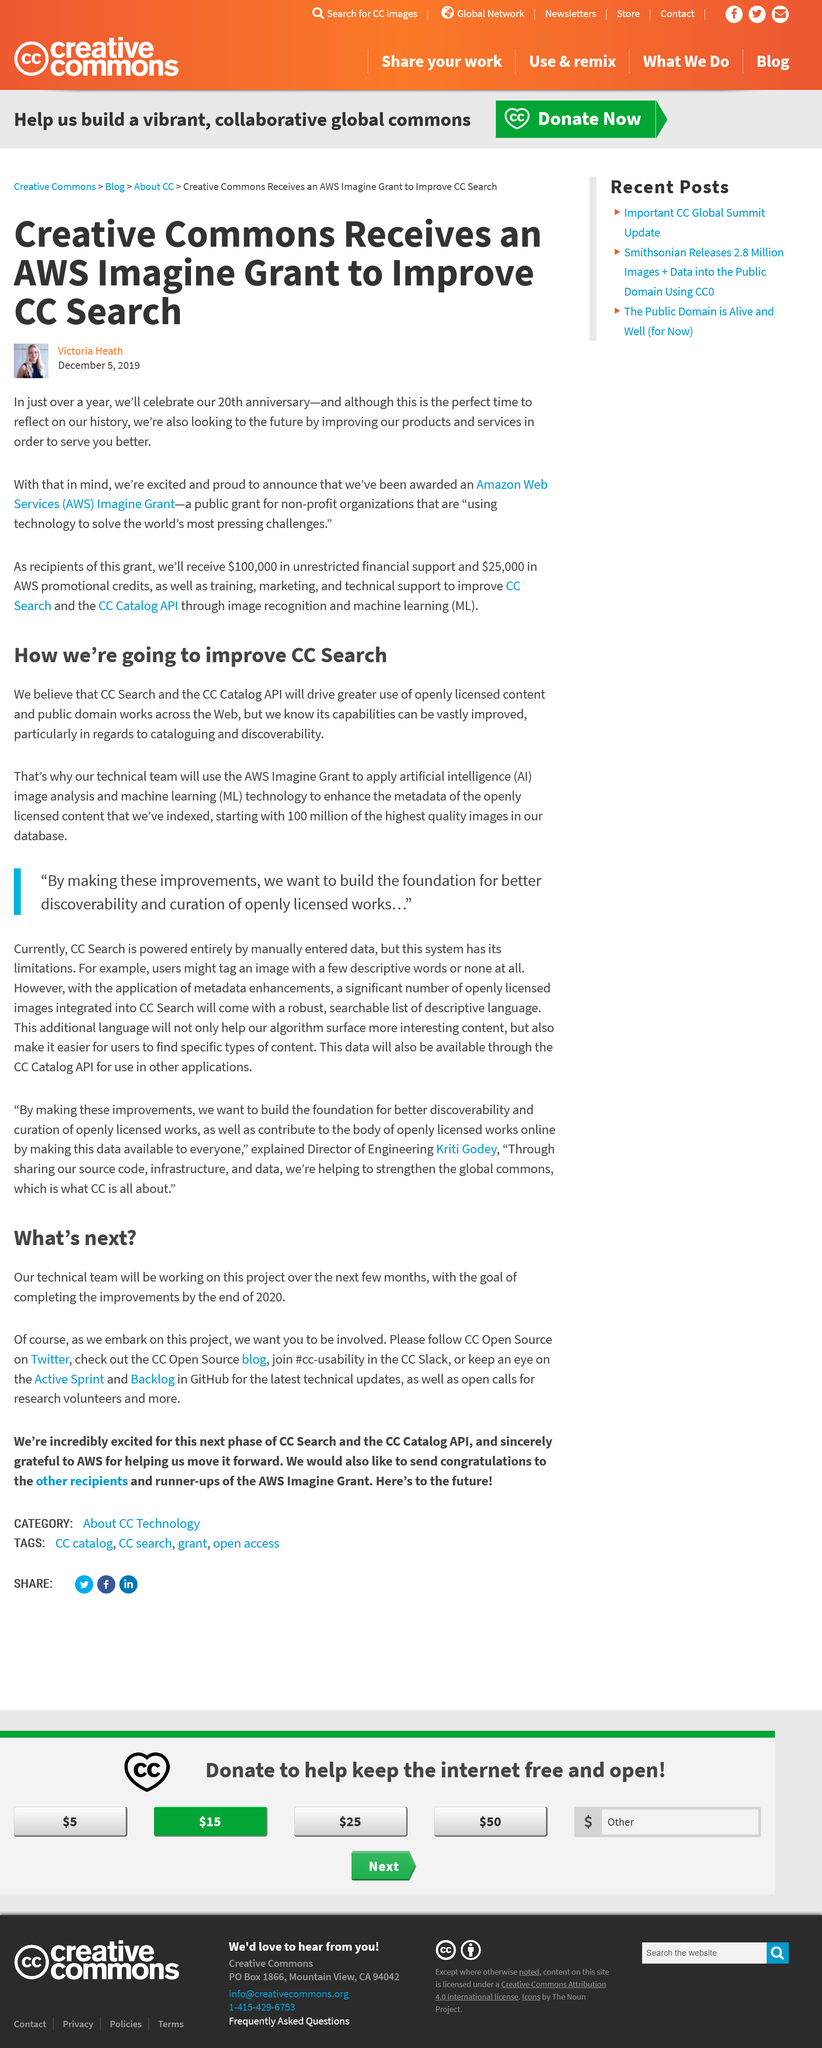List a handful of essential elements in this visual. The CC Search tech team will be using the AWS Imagine Grant to fund their project. Creative Commons has been awarded an Amazon Web Services (AWS) grant. Creative Commons is celebrating its 20th anniversary. The AWS grant will be used to support organizations that utilize technology to address the most critical issues facing our world, such as climate change, poverty, lack of access to education and healthcare, and social inequality. The technical team will begin with 100 million images. 